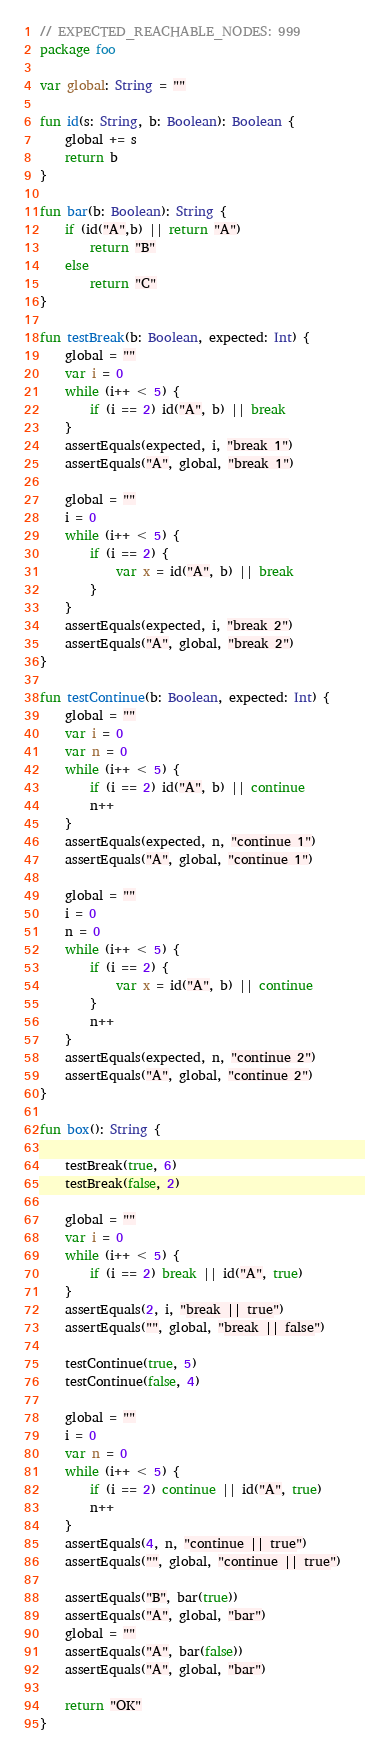Convert code to text. <code><loc_0><loc_0><loc_500><loc_500><_Kotlin_>// EXPECTED_REACHABLE_NODES: 999
package foo

var global: String = ""

fun id(s: String, b: Boolean): Boolean {
    global += s
    return b
}

fun bar(b: Boolean): String {
    if (id("A",b) || return "A")
        return "B"
    else
        return "C"
}

fun testBreak(b: Boolean, expected: Int) {
    global = ""
    var i = 0
    while (i++ < 5) {
        if (i == 2) id("A", b) || break
    }
    assertEquals(expected, i, "break 1")
    assertEquals("A", global, "break 1")

    global = ""
    i = 0
    while (i++ < 5) {
        if (i == 2) {
            var x = id("A", b) || break
        }
    }
    assertEquals(expected, i, "break 2")
    assertEquals("A", global, "break 2")
}

fun testContinue(b: Boolean, expected: Int) {
    global = ""
    var i = 0
    var n = 0
    while (i++ < 5) {
        if (i == 2) id("A", b) || continue
        n++
    }
    assertEquals(expected, n, "continue 1")
    assertEquals("A", global, "continue 1")

    global = ""
    i = 0
    n = 0
    while (i++ < 5) {
        if (i == 2) {
            var x = id("A", b) || continue
        }
        n++
    }
    assertEquals(expected, n, "continue 2")
    assertEquals("A", global, "continue 2")
}

fun box(): String {

    testBreak(true, 6)
    testBreak(false, 2)

    global = ""
    var i = 0
    while (i++ < 5) {
        if (i == 2) break || id("A", true)
    }
    assertEquals(2, i, "break || true")
    assertEquals("", global, "break || false")

    testContinue(true, 5)
    testContinue(false, 4)

    global = ""
    i = 0
    var n = 0
    while (i++ < 5) {
        if (i == 2) continue || id("A", true)
        n++
    }
    assertEquals(4, n, "continue || true")
    assertEquals("", global, "continue || true")

    assertEquals("B", bar(true))
    assertEquals("A", global, "bar")
    global = ""
    assertEquals("A", bar(false))
    assertEquals("A", global, "bar")

    return "OK"
}</code> 